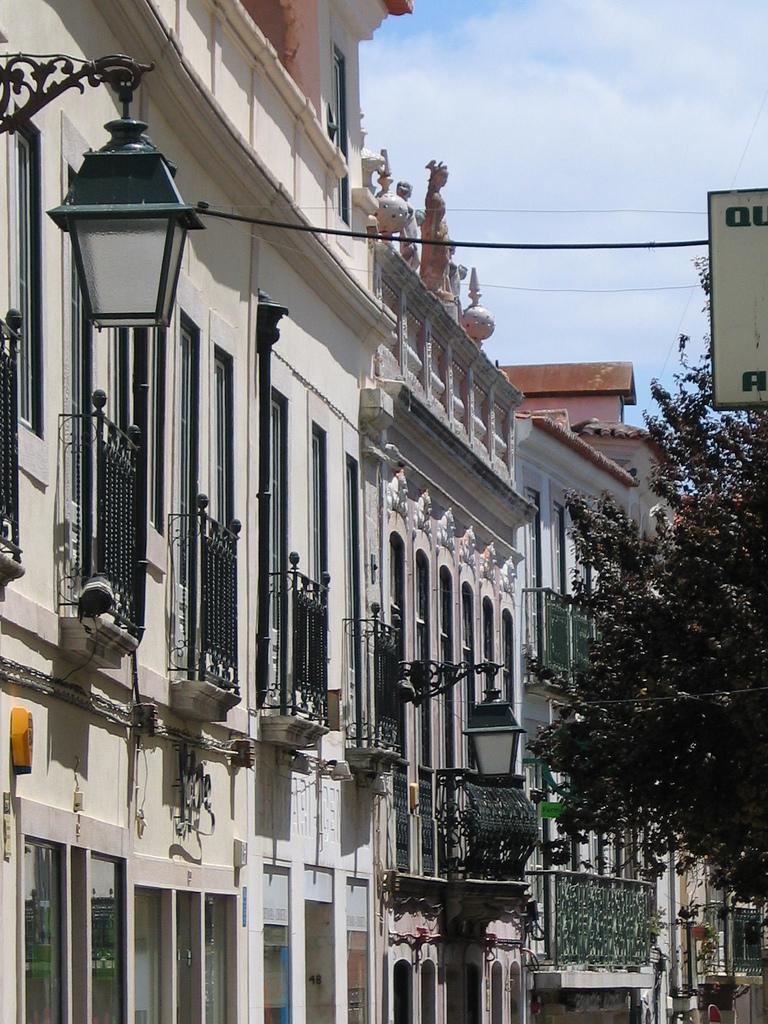Please provide a concise description of this image. In this image we can see some buildings with windows and the railing. We can also see some street lamps, a tree, a board with some text on it, some wires and the sky which looks cloudy. 